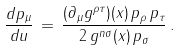Convert formula to latex. <formula><loc_0><loc_0><loc_500><loc_500>\frac { d p _ { \mu } } { d u } \, = \, \frac { ( \partial _ { \mu } g ^ { \rho \tau } ) ( x ) \, p _ { \rho } \, p _ { \tau } } { 2 \, g ^ { n \sigma } ( x ) \, p _ { \sigma } } \, .</formula> 